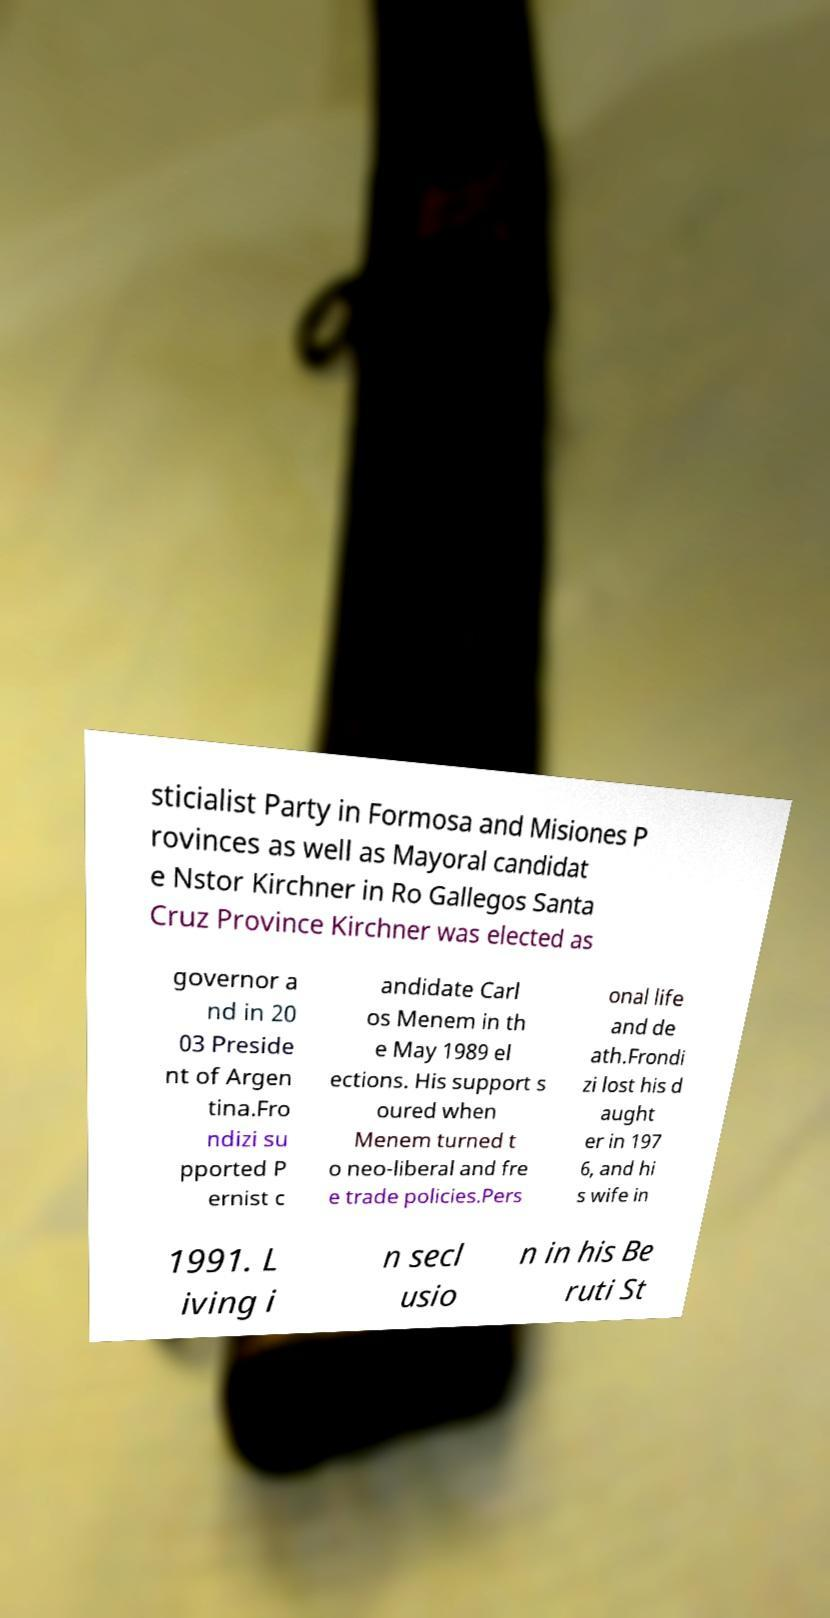Could you extract and type out the text from this image? sticialist Party in Formosa and Misiones P rovinces as well as Mayoral candidat e Nstor Kirchner in Ro Gallegos Santa Cruz Province Kirchner was elected as governor a nd in 20 03 Preside nt of Argen tina.Fro ndizi su pported P ernist c andidate Carl os Menem in th e May 1989 el ections. His support s oured when Menem turned t o neo-liberal and fre e trade policies.Pers onal life and de ath.Frondi zi lost his d aught er in 197 6, and hi s wife in 1991. L iving i n secl usio n in his Be ruti St 